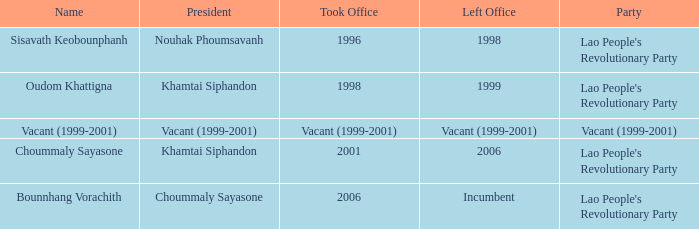What is Party, when Took Office is 1998? Lao People's Revolutionary Party. 